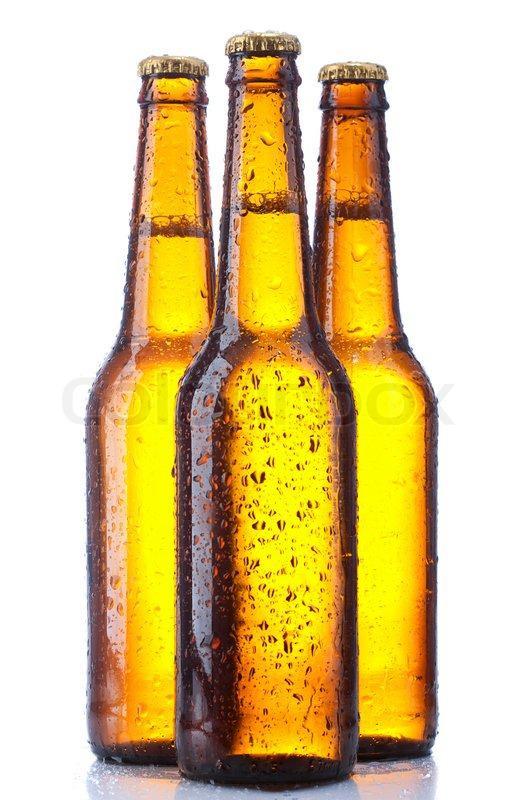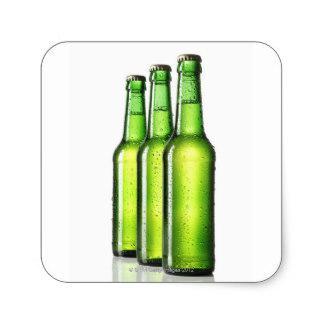The first image is the image on the left, the second image is the image on the right. Evaluate the accuracy of this statement regarding the images: "All beer bottles are standing upright.". Is it true? Answer yes or no. Yes. The first image is the image on the left, the second image is the image on the right. Given the left and right images, does the statement "There are three green glass bottles" hold true? Answer yes or no. Yes. 